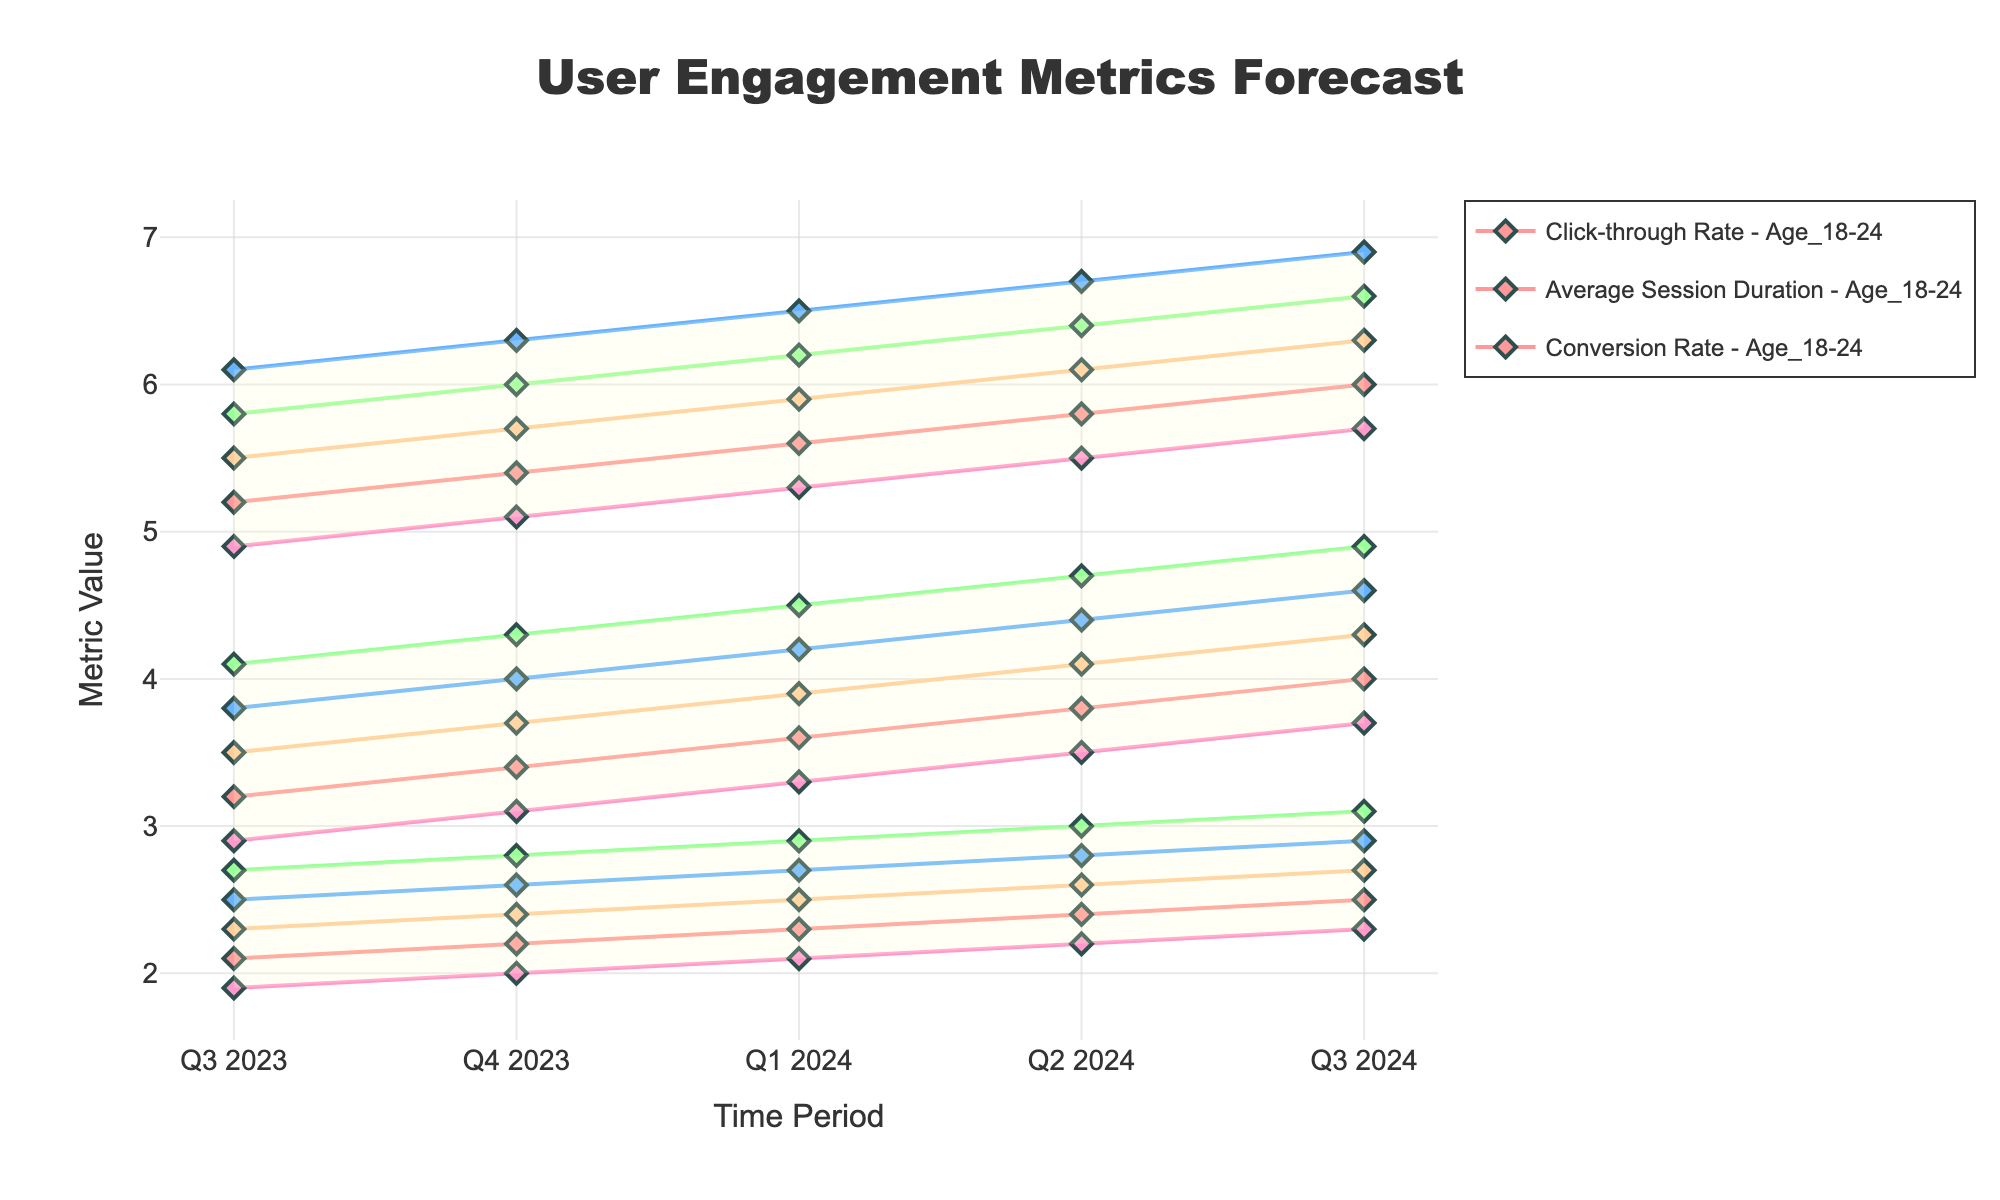What is the title of the chart? The title of the chart is located at the top center of the figure and is surrounded by a slightly larger and bold font for visibility. It reads "User Engagement Metrics Forecast".
Answer: User Engagement Metrics Forecast What is the Click-through Rate for the age group 25-34 in Q3 2023? Locate the `Click-through Rate` segment on the x-axis and follow the line marked for the age group 25-34 at Q3 2023.
Answer: 3.8 How does the Conversion Rate change from Q3 2023 to Q3 2024 for the age group 55+? Examine the Conversion Rate section and observe the values for the age group 55+ at both Q3 2023 and Q3 2024. You can see the value increases from 1.9 to 2.3.
Answer: Increases from 1.9 to 2.3 Which age group shows the highest Click-through Rate in Q1 2024? In the Click-through Rate metric for Q1 2024, compare the values for each age group. The highest value is 4.5 for the age group 35-44.
Answer: Age 35-44 By how much does the Average Session Duration for the age group 45-54 increase from Q3 2023 to Q3 2024? Look at the data for the Average Session Duration in Q3 2023 and Q3 2024 for the age group 45-54. Subtract the Q3 2023 value (5.5) from the Q3 2024 value (6.3).
Answer: 0.8 Which metric shows the most substantial increase for the age group 18-24 between Q3 2023 and Q3 2024? Check all metrics for the age group 18-24. Calculate the difference for Click-through Rate (4.0 - 3.2 = 0.8), Average Session Duration (6.0 - 5.2 = 0.8), and Conversion Rate (2.5 - 2.1 = 0.4). The most substantial increase is 0.8 for both Click-through Rate and Average Session Duration.
Answer: Click-through Rate and Average Session Duration Is there any metric for which the age group 55+ consistently has the lowest values throughout the forecast? For each metric, you can see if the values for the age group 55+ are the lowest when compared to other age groups. The age group 55+ consistently has the lowest values throughout the forecast for all three metrics.
Answer: Yes During which time period does the 18-24 age group reach the highest Conversion Rate? Observe the Conversion Rate line for the 18-24 age group across all time periods and find the highest value, which occurs at Q3 2024 with a value of 2.5.
Answer: Q3 2024 